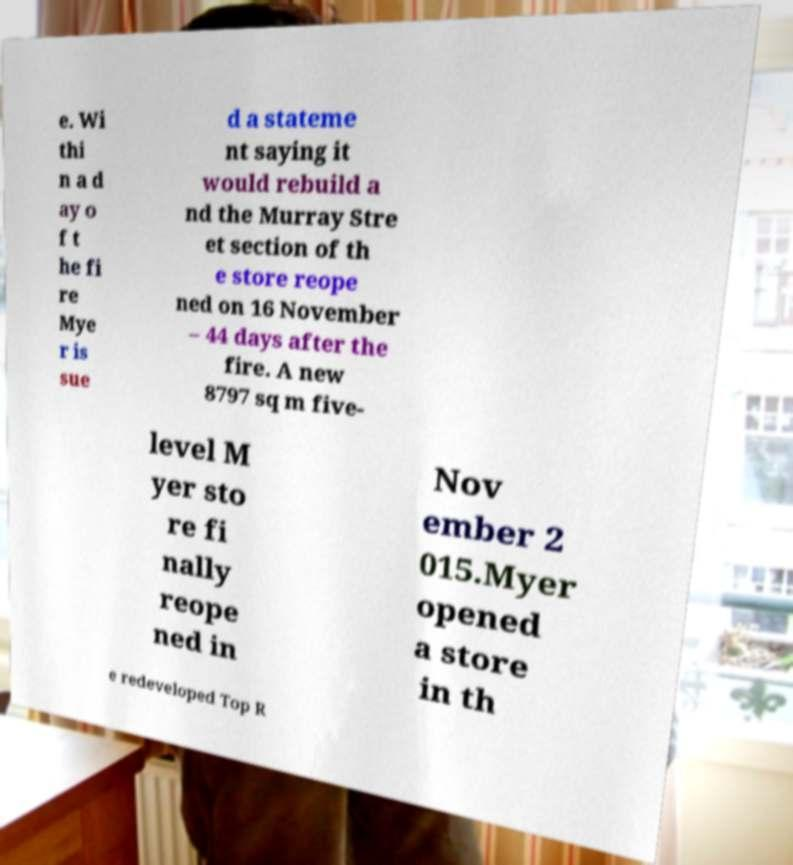What messages or text are displayed in this image? I need them in a readable, typed format. e. Wi thi n a d ay o f t he fi re Mye r is sue d a stateme nt saying it would rebuild a nd the Murray Stre et section of th e store reope ned on 16 November – 44 days after the fire. A new 8797 sq m five- level M yer sto re fi nally reope ned in Nov ember 2 015.Myer opened a store in th e redeveloped Top R 